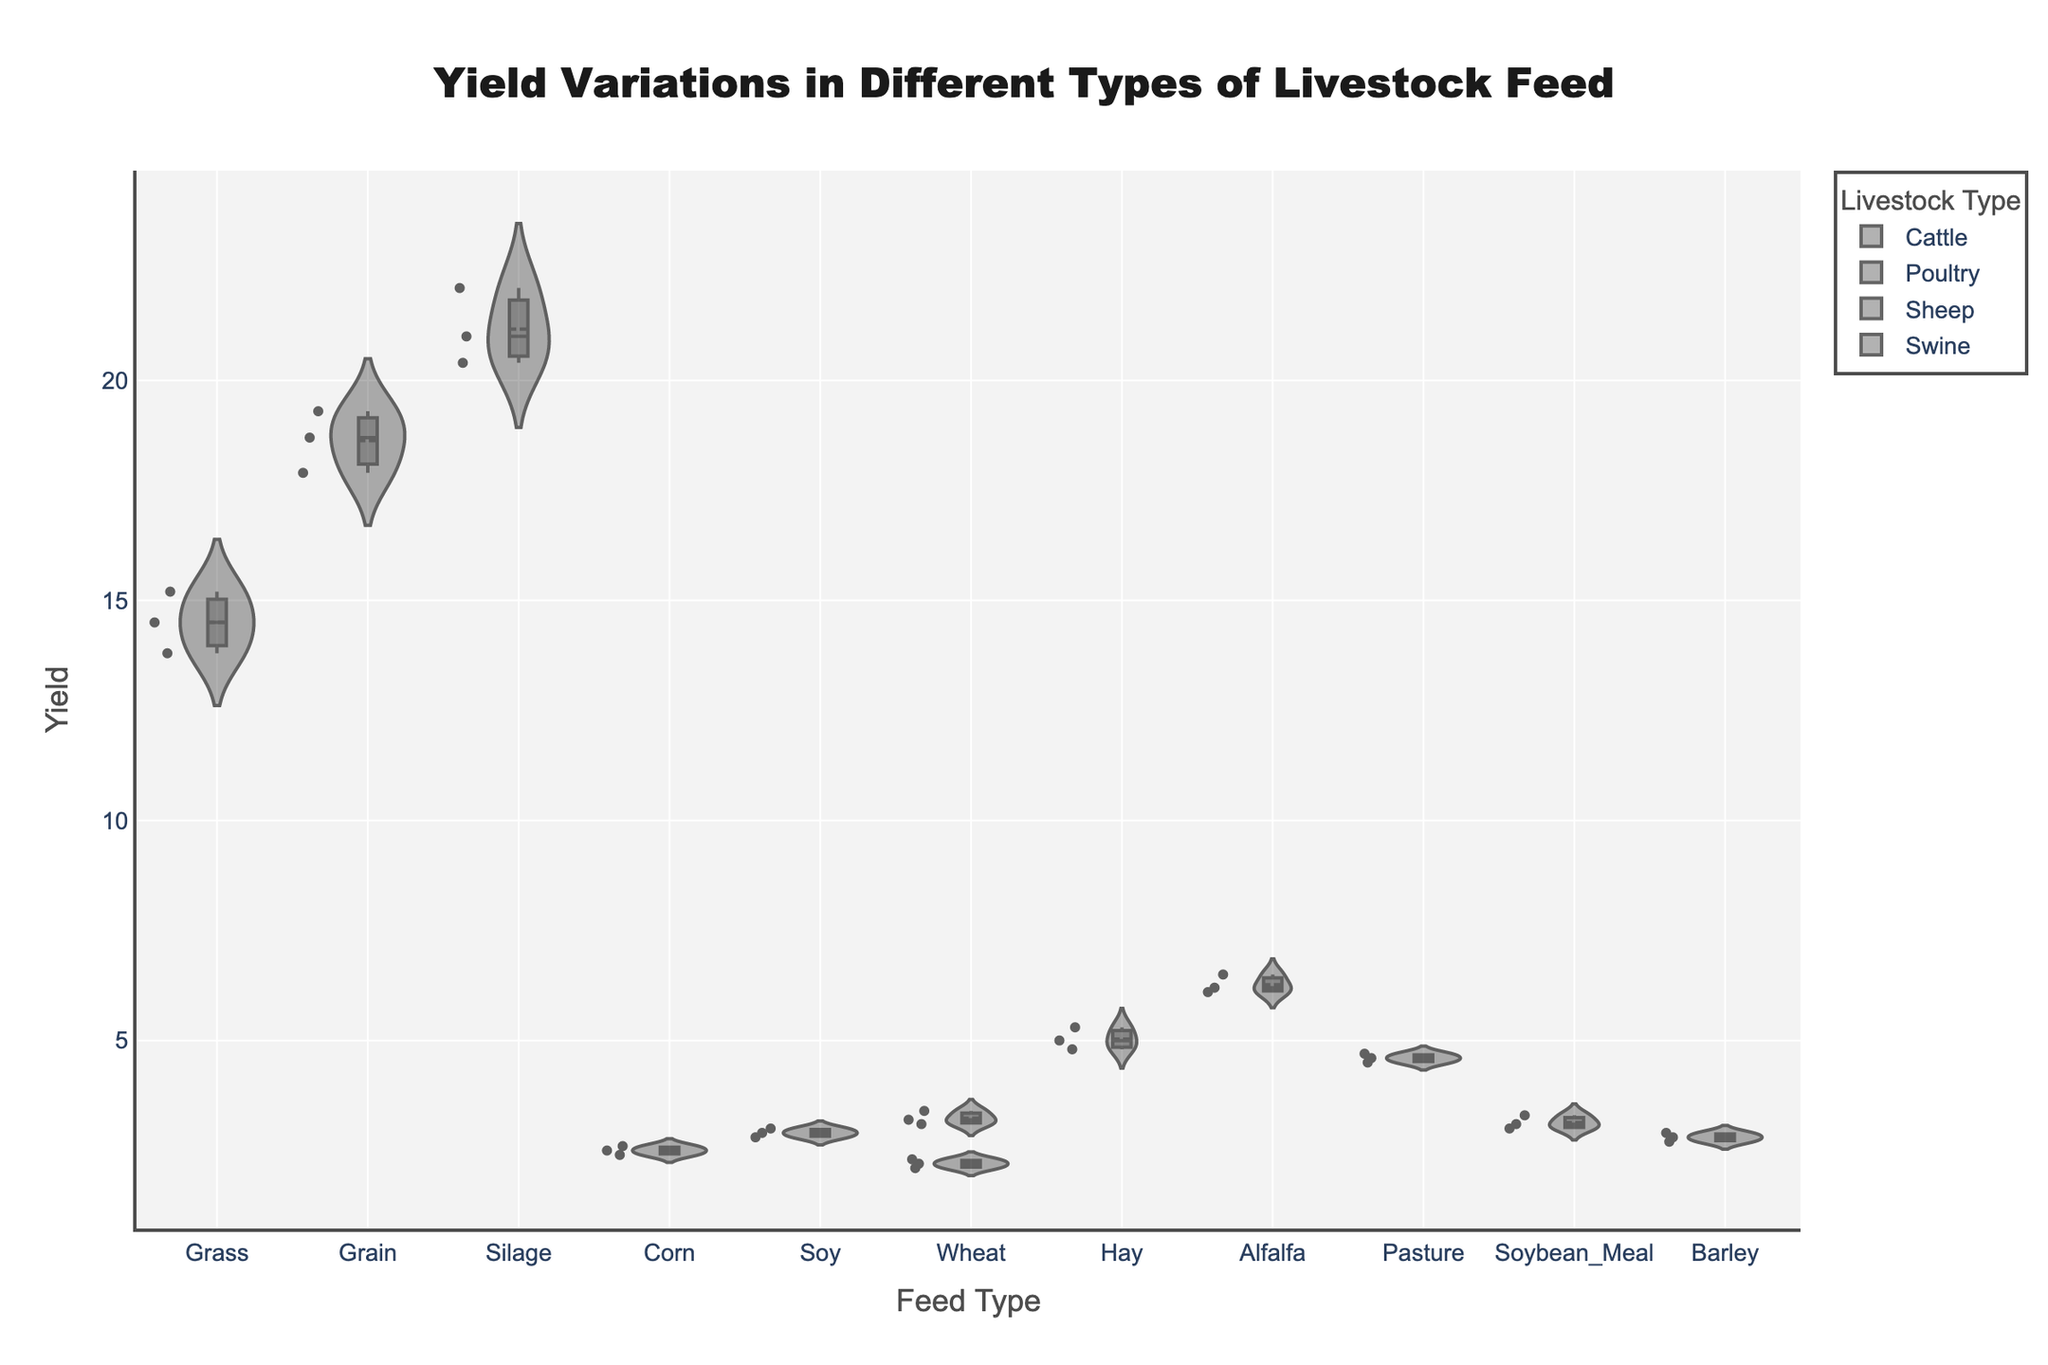What is the title of the plot? The title of the plot is located at the top of the chart and is usually in a larger font size for emphasis. This title introduces the main subject matter of the plot.
Answer: Yield Variations in Different Types of Livestock Feed What are the axis titles in the plot? The x-axis and y-axis titles describe the data shown along the respective axes. The x-axis title is usually located below the horizontal axis, and the y-axis title is to the left of the vertical axis. These titles help in understanding the variables involved.
Answer: Feed Type (x-axis), Yield (y-axis) How many different livestock types are represented in the plot? Each violin plot typically differentiates groups using color and/or legend entries, which can be counted in the legend.
Answer: Four Which livestock type generally has the highest yield on average and with what feed type? By looking at the position and spread of the violins and comparing their central tendencies (mean lines or box plots), we can determine which livestock/feed combination has the highest average yield. For each livestock, the feed type with the highest position in terms of yield indicates the maximum average.
Answer: Cattle with Silage How does the yield for Poultry fed with Corn compare to Poultry fed with Soy? This question is about comparing the positions of the violins and/or box plots for Poultry on Corn and Soy feeds.
Answer: Soy-fed Poultry yields higher than Corn-fed Poultry Which livestock type has the lowest yield variation among its feed types? Yield variation can be assessed by the spread of the violin plots. The narrower the violin, the lower the variation. Evaluating the box plots also helps in understanding the variance.
Answer: Poultry For Cattle, which feed type shows the smallest spread in yield? The spread can be seen by the width of the violin plot and the length of the whiskers in the box plot. The feed with the smallest spread will have the narrowest violin plot and/or shortest whiskers.
Answer: Grass What is the median yield for Sheep fed with Hay? The median is represented by the line in the middle of the box in the box plot. By inspecting the position of this line within the violin plot for Sheep fed with Hay, we can find the median yield value.
Answer: 5.0 Which feed type shows the highest maximum yield for Swine? The maximum yield for each feed type in Swine can be found by looking for the topmost point within the respective violin plot or the upper whisker in the box plot.
Answer: Wheat Comparing Sheep fed with Alfalfa and Sheep fed with Hay, which feed type results in higher central tendency and by how much? By comparing the central tendency (e.g., median) of the box plots for Alfalfa and Hay feeds, we can determine which has a higher yield. The difference between these central tendency points gives the amount by which one feed type outperforms the other.
Answer: Sheep on Alfalfa have a higher median by 1.2 